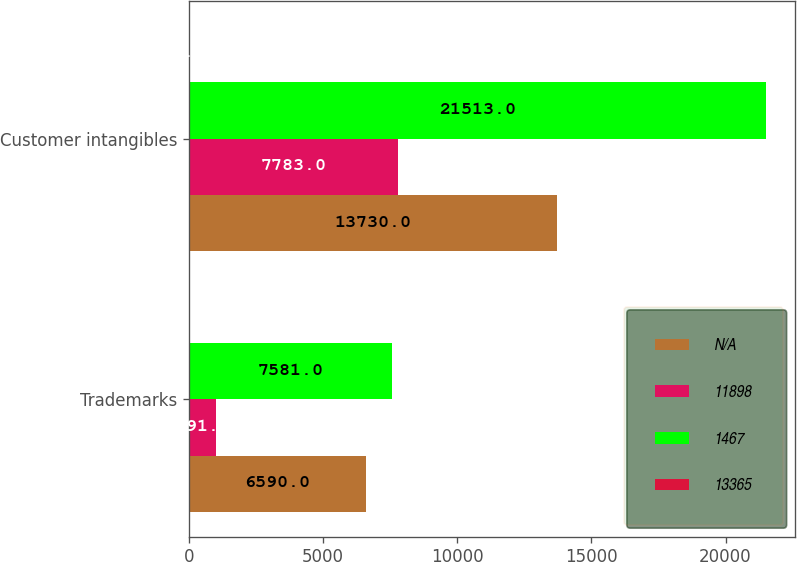<chart> <loc_0><loc_0><loc_500><loc_500><stacked_bar_chart><ecel><fcel>Trademarks<fcel>Customer intangibles<nl><fcel>nan<fcel>6590<fcel>13730<nl><fcel>11898<fcel>991<fcel>7783<nl><fcel>1467<fcel>7581<fcel>21513<nl><fcel>13365<fcel>15<fcel>9<nl></chart> 